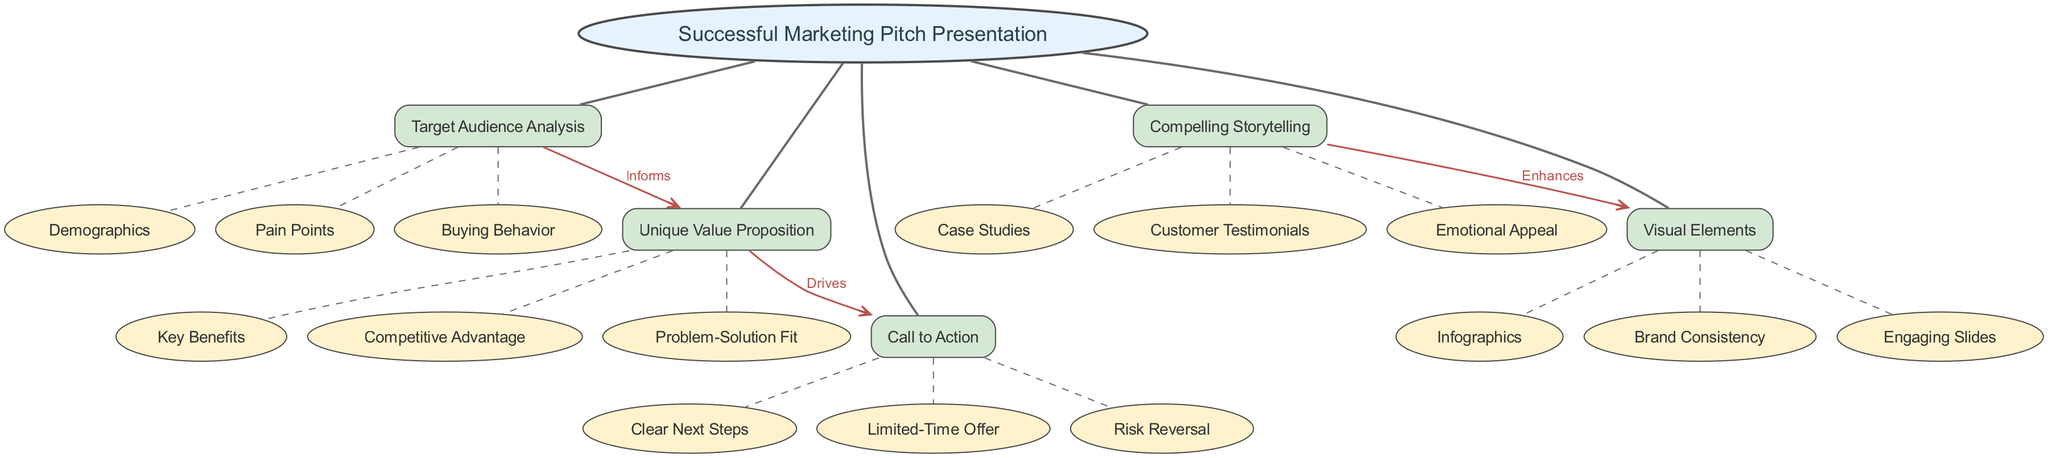What is the central concept of the diagram? The diagram presents "Successful Marketing Pitch Presentation" as the central concept, which is indicated prominently at the top in an ellipse shape.
Answer: Successful Marketing Pitch Presentation How many main components are there? There are five main components listed in the diagram. Each component is connected to the central concept node.
Answer: 5 Which component informs the Unique Value Proposition? The "Target Audience Analysis" component is shown to inform the "Unique Value Proposition" through a directed edge labeled "Informs."
Answer: Target Audience Analysis What enhances the Visual Elements? The edge labeled "Enhances" connects "Compelling Storytelling" to "Visual Elements", indicating that storytelling enhances visual aspects of the presentation.
Answer: Compelling Storytelling Which component drives the Call to Action? The "Unique Value Proposition" is indicated as driving the "Call to Action" in the diagram, marked by the directed edge labeled "Drives."
Answer: Unique Value Proposition Explain the relationship between Compelling Storytelling and Visual Elements? The edge labeled "Enhances" shows that "Compelling Storytelling" improves or adds value to the "Visual Elements," suggesting a supportive relationship.
Answer: Enhances How many sub-elements are there under Unique Value Proposition? There are three sub-elements listed beneath the "Unique Value Proposition" component. These are Key Benefits, Competitive Advantage, and Problem-Solution Fit.
Answer: 3 What is the role of Call to Action in a marketing pitch presentation? The "Call to Action" is represented as a concluding element that prompts the audience to take specific actions, driven by the preceding components.
Answer: Prompts specific actions Which sub-element is part of the Target Audience Analysis? "Demographics" is one of the sub-elements included in the "Target Audience Analysis" component, as outlined in the diagram.
Answer: Demographics 